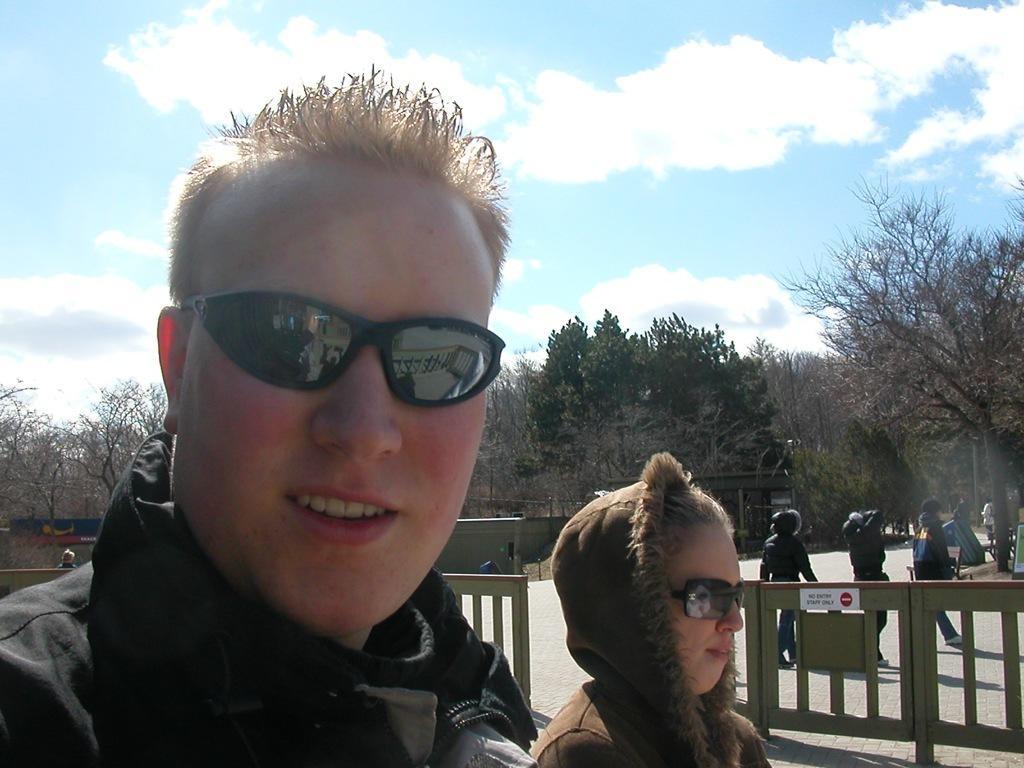Please provide a concise description of this image. In the foreground of this image, there is a man and beside him, there is a woman wearing hoodie. In the background, there is a wooden railing, few persons walking on the road, trees, sky and the cloud. 